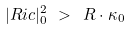<formula> <loc_0><loc_0><loc_500><loc_500>| R i c | ^ { 2 } _ { 0 } \ > \ R \cdot \kappa _ { 0 }</formula> 